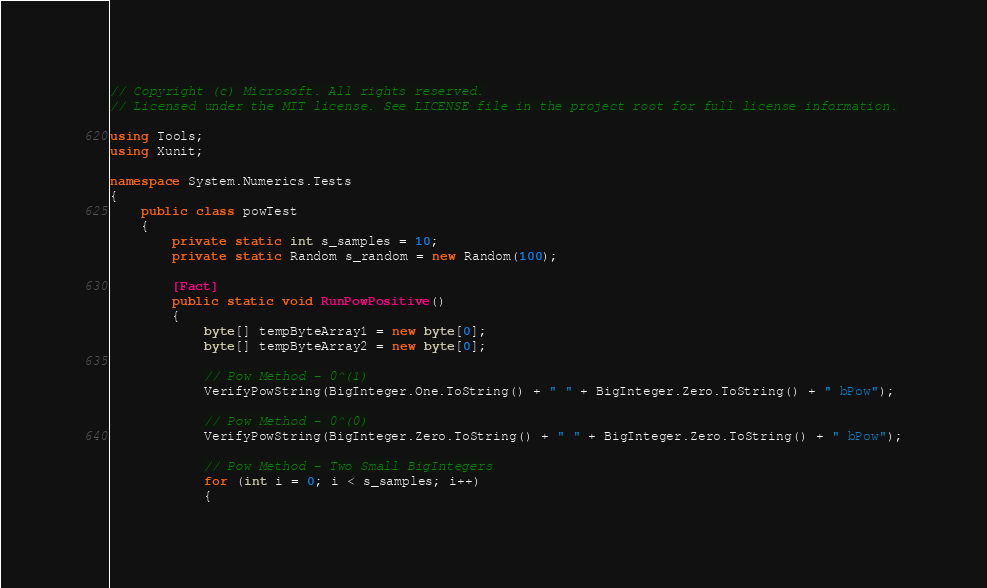Convert code to text. <code><loc_0><loc_0><loc_500><loc_500><_C#_>// Copyright (c) Microsoft. All rights reserved.
// Licensed under the MIT license. See LICENSE file in the project root for full license information.

using Tools;
using Xunit;

namespace System.Numerics.Tests
{
    public class powTest
    {
        private static int s_samples = 10;
        private static Random s_random = new Random(100);

        [Fact]
        public static void RunPowPositive()
        {
            byte[] tempByteArray1 = new byte[0];
            byte[] tempByteArray2 = new byte[0];

            // Pow Method - 0^(1)
            VerifyPowString(BigInteger.One.ToString() + " " + BigInteger.Zero.ToString() + " bPow");

            // Pow Method - 0^(0)
            VerifyPowString(BigInteger.Zero.ToString() + " " + BigInteger.Zero.ToString() + " bPow");

            // Pow Method - Two Small BigIntegers
            for (int i = 0; i < s_samples; i++)
            {</code> 